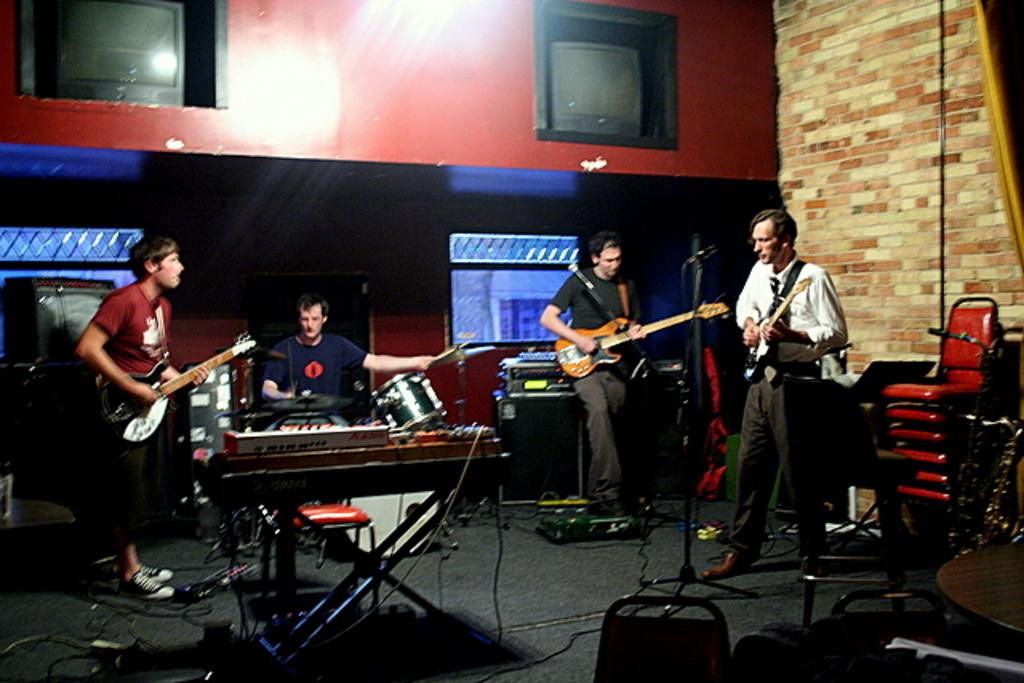What are the people in the image doing? The people in the image are standing and holding guitars. Can you describe the man's position in the image? The man is sitting in the image. What is the man sitting next to? The man is sitting next to a drum set. What type of fang can be seen in the image? There is no fang present in the image. What kind of paper is the man reading while sitting next to the drum set? The man is not reading any paper in the image; he is sitting next to a drum set. 